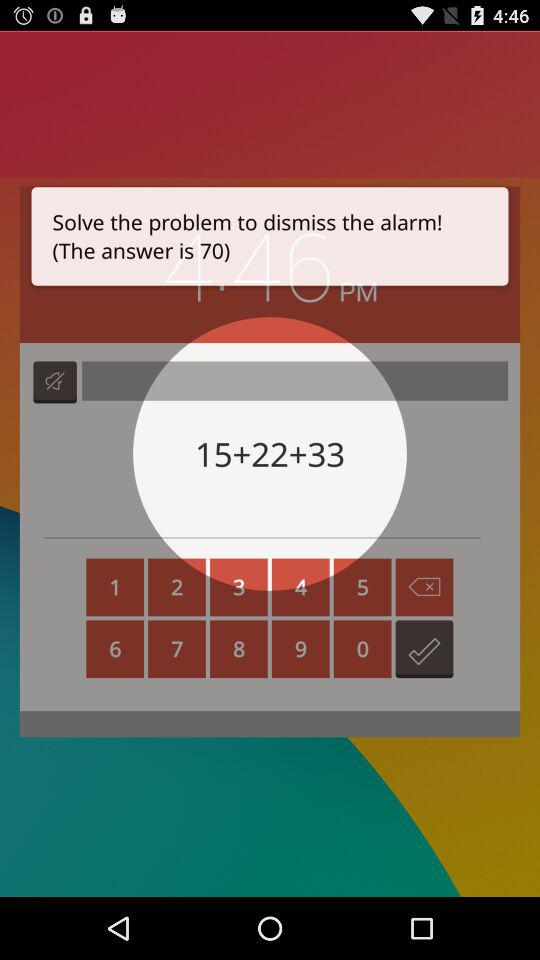What is the sum of 15+22+33? The sum is 70. 